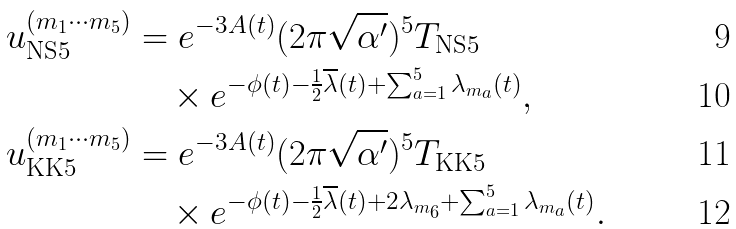Convert formula to latex. <formula><loc_0><loc_0><loc_500><loc_500>u _ { \text {NS} 5 } ^ { ( m _ { 1 } \cdots m _ { 5 } ) } & = e ^ { - 3 A ( t ) } ( 2 \pi \sqrt { \alpha ^ { \prime } } ) ^ { 5 } T _ { \text {NS} 5 } \\ & \quad \times e ^ { - \phi ( t ) - \frac { 1 } { 2 } \overline { \lambda } ( t ) + \sum _ { a = 1 } ^ { 5 } \lambda _ { m _ { a } } ( t ) } , \\ u _ { \text {KK} 5 } ^ { ( m _ { 1 } \cdots m _ { 5 } ) } & = e ^ { - 3 A ( t ) } ( 2 \pi \sqrt { \alpha ^ { \prime } } ) ^ { 5 } T _ { \text {KK} 5 } \\ & \quad \times e ^ { - \phi ( t ) - \frac { 1 } { 2 } \overline { \lambda } ( t ) + 2 \lambda _ { m _ { 6 } } + \sum _ { a = 1 } ^ { 5 } \lambda _ { m _ { a } } ( t ) } .</formula> 